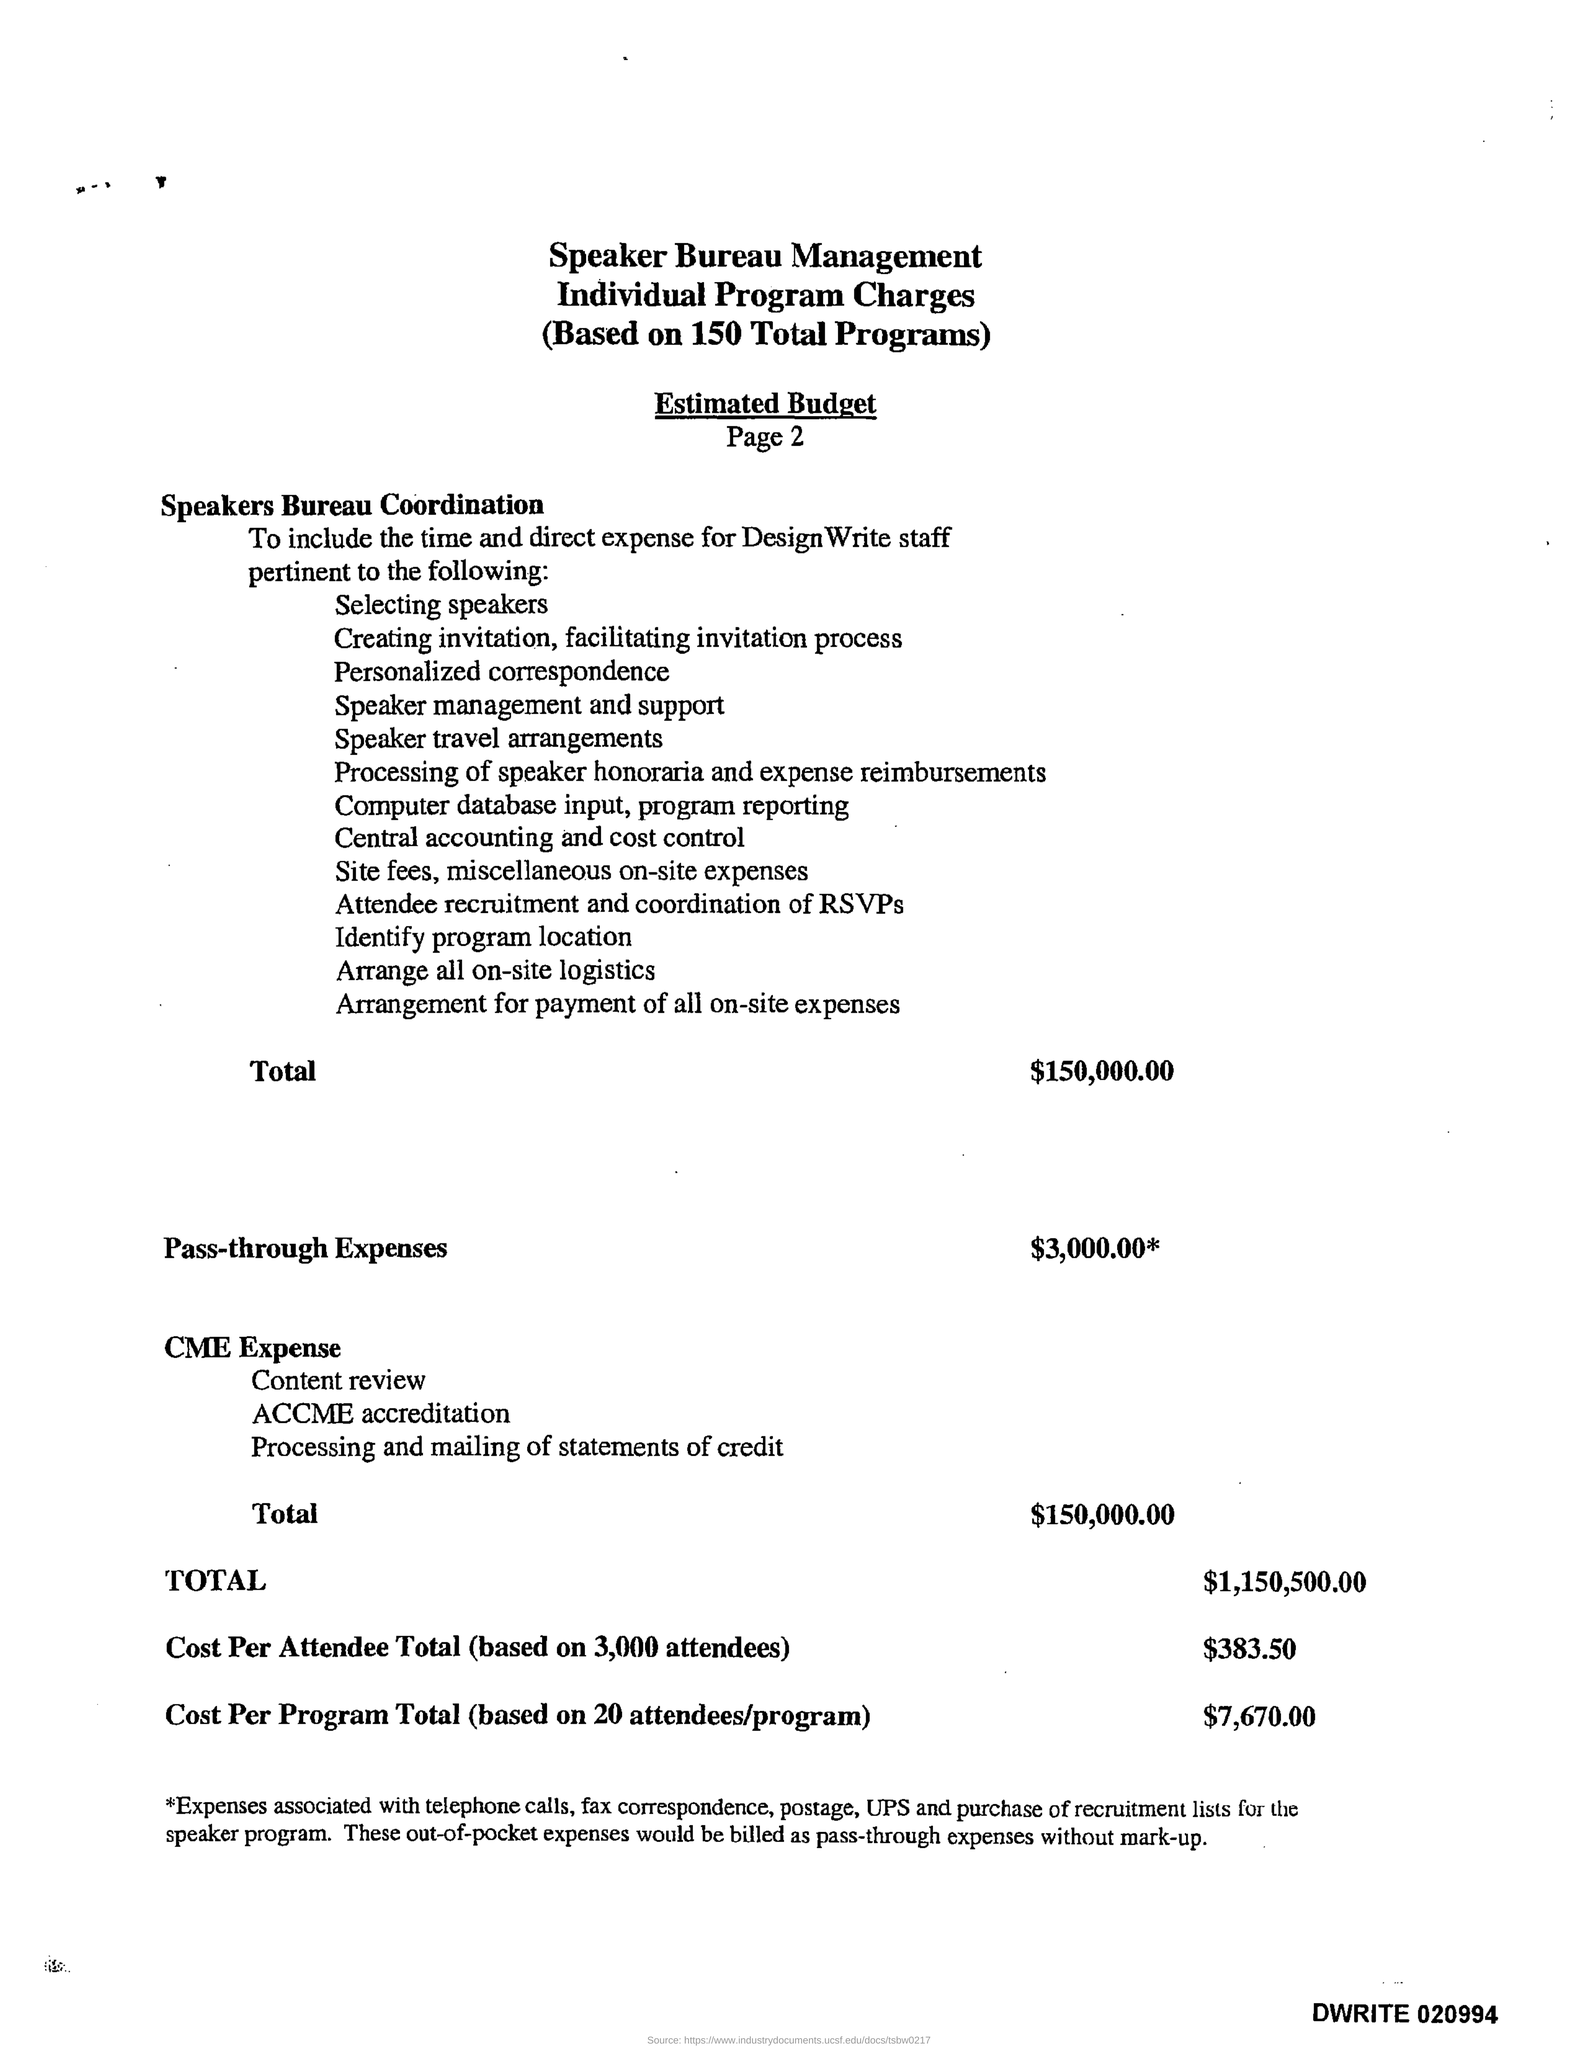Mention a couple of crucial points in this snapshot. The cost per program total, based on 20 attendees per program, is approximately 7,670.00. The estimated budget for pass-through expenses is $3,000.00. The cost per attendee for the conference would be approximately $383.50 for 3,000 attendees. The total estimated budget for speakers bureau coordination is 150,000.00. The estimated total budget for CME expenses is $150,000.00. 